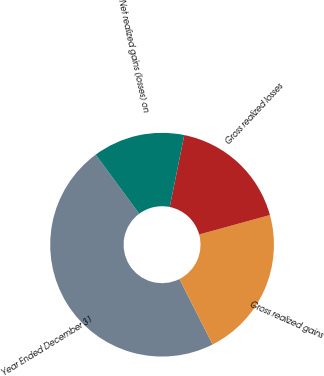Convert chart to OTSL. <chart><loc_0><loc_0><loc_500><loc_500><pie_chart><fcel>Year Ended December 31<fcel>Gross realized gains<fcel>Gross realized losses<fcel>Net realized gains (losses) on<nl><fcel>47.35%<fcel>21.81%<fcel>17.55%<fcel>13.29%<nl></chart> 